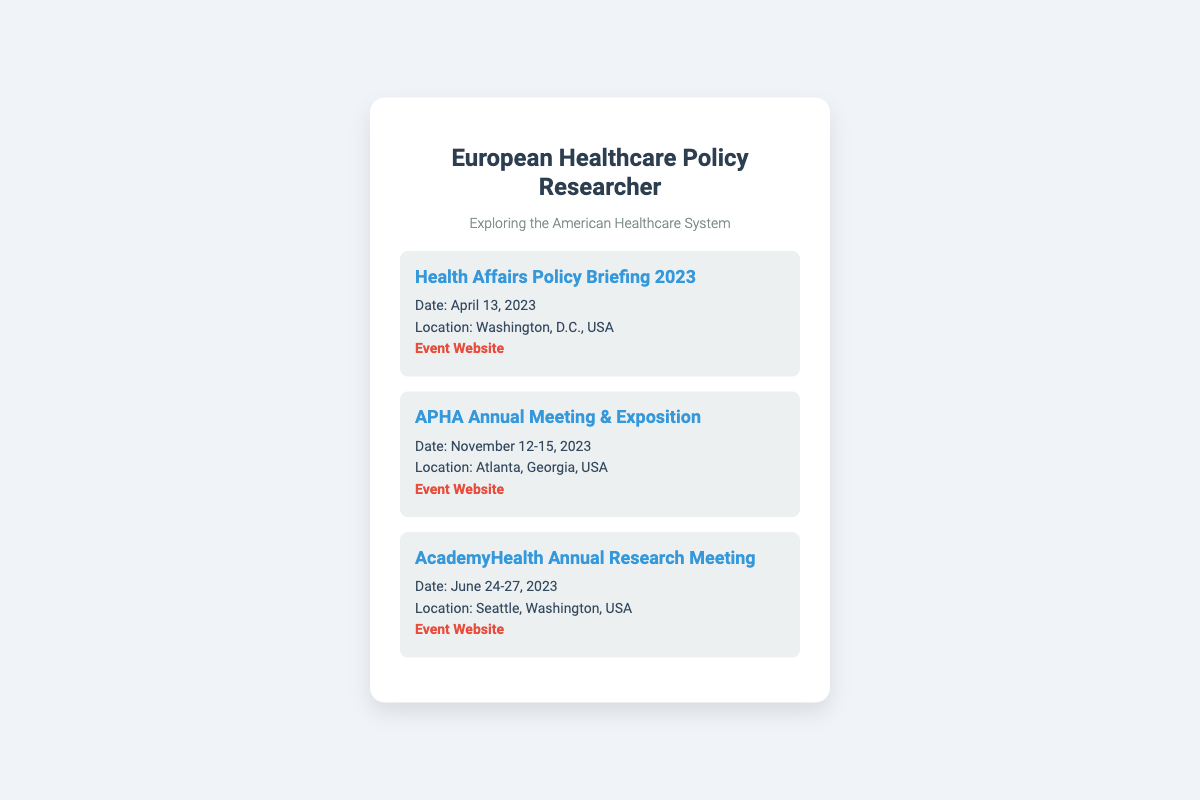what is the date of the Health Affairs Policy Briefing 2023? The date is mentioned directly under the conference title in the document.
Answer: April 13, 2023 where is the APHA Annual Meeting & Exposition located? The location is specified in the conference details provided in the document.
Answer: Atlanta, Georgia, USA what is the website for the AcademyHealth Annual Research Meeting? The event website is provided as a hyperlink in the conference section of the document.
Answer: https://www.academyhealth.org/events/site/annual-research-meeting-arm how many days does the APHA Annual Meeting & Exposition last? The duration is provided as a range of dates in the document.
Answer: 4 days which conference is taking place in Seattle? The location detail specifies which conference is held there.
Answer: AcademyHealth Annual Research Meeting what is the subtitle on the business card? The subtitle is indicated clearly below the main title on the card.
Answer: Exploring the American Healthcare System which conference occurs first in 2023? The order is determined based on the dates listed for each conference in the document.
Answer: Health Affairs Policy Briefing 2023 what is the name of the person on the business card? The name is provided at the top of the business card in the header section.
Answer: European Healthcare Policy Researcher 